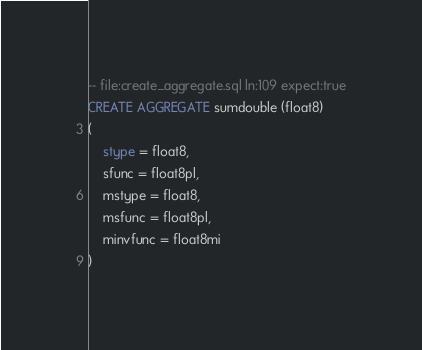<code> <loc_0><loc_0><loc_500><loc_500><_SQL_>-- file:create_aggregate.sql ln:109 expect:true
CREATE AGGREGATE sumdouble (float8)
(
    stype = float8,
    sfunc = float8pl,
    mstype = float8,
    msfunc = float8pl,
    minvfunc = float8mi
)
</code> 